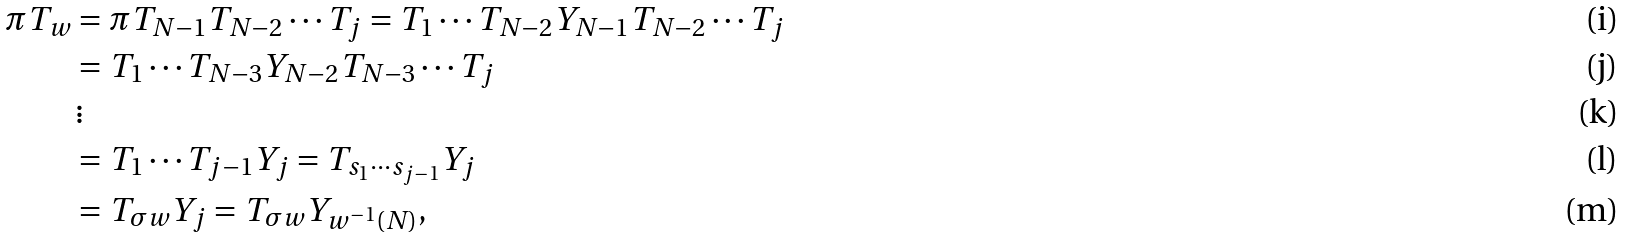<formula> <loc_0><loc_0><loc_500><loc_500>\pi T _ { w } & = \pi T _ { N - 1 } T _ { N - 2 } \cdots T _ { j } = T _ { 1 } \cdots T _ { N - 2 } Y _ { N - 1 } T _ { N - 2 } \cdots T _ { j } \\ & = T _ { 1 } \cdots T _ { N - 3 } Y _ { N - 2 } T _ { N - 3 } \cdots T _ { j } \\ & \, \vdots \\ & = T _ { 1 } \cdots T _ { j - 1 } Y _ { j } = T _ { s _ { 1 } \cdots s _ { j - 1 } } Y _ { j } \\ & = T _ { \sigma w } Y _ { j } = T _ { \sigma w } Y _ { w ^ { - 1 } ( N ) } ,</formula> 